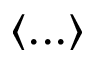Convert formula to latex. <formula><loc_0><loc_0><loc_500><loc_500>\langle \dots \rangle</formula> 